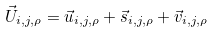<formula> <loc_0><loc_0><loc_500><loc_500>\vec { U } _ { i , j , \rho } = \vec { u } _ { i , j , \rho } + \vec { s } _ { i , j , \rho } + \vec { v } _ { i , j , \rho }</formula> 